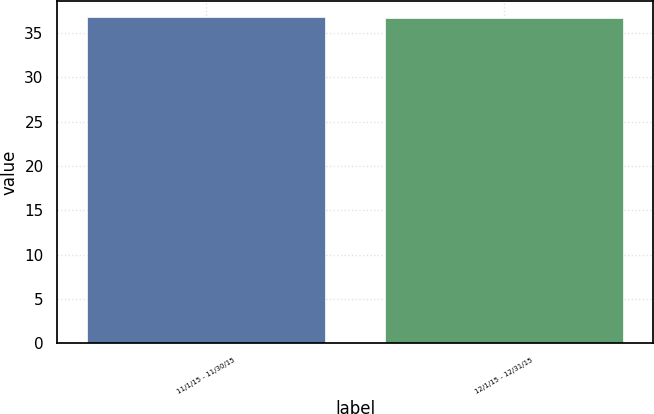Convert chart. <chart><loc_0><loc_0><loc_500><loc_500><bar_chart><fcel>11/1/15 - 11/30/15<fcel>12/1/15 - 12/31/15<nl><fcel>36.8<fcel>36.71<nl></chart> 